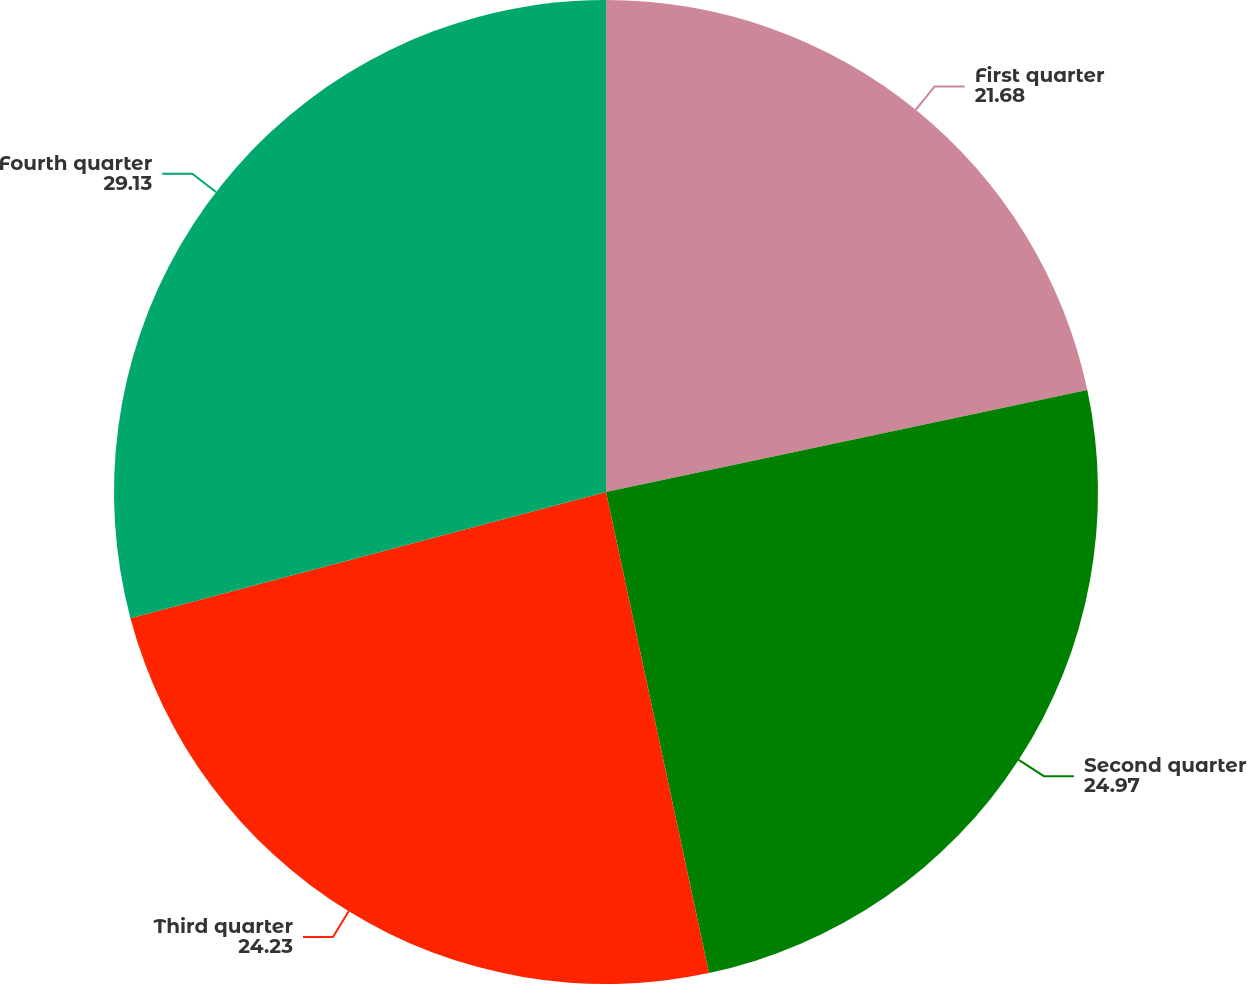Convert chart to OTSL. <chart><loc_0><loc_0><loc_500><loc_500><pie_chart><fcel>First quarter<fcel>Second quarter<fcel>Third quarter<fcel>Fourth quarter<nl><fcel>21.68%<fcel>24.97%<fcel>24.23%<fcel>29.13%<nl></chart> 